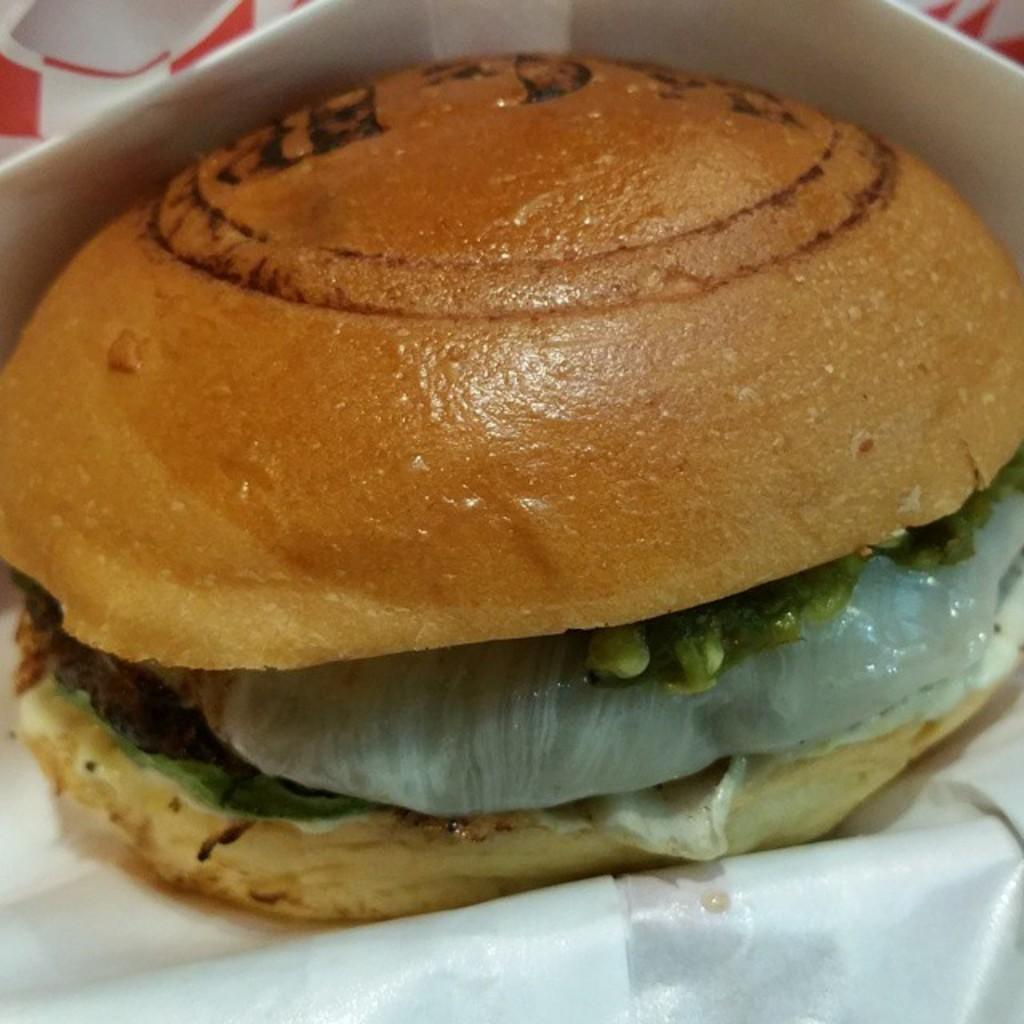What type of food is shown in the image? There is a burger in the image. What is the color of the burger? The burger has a brown color. What type of gate can be seen in the image? There is no gate present in the image; it only features a burger. How does the burger sort the different ingredients? The burger does not sort ingredients, as it is a static image of a completed dish. 